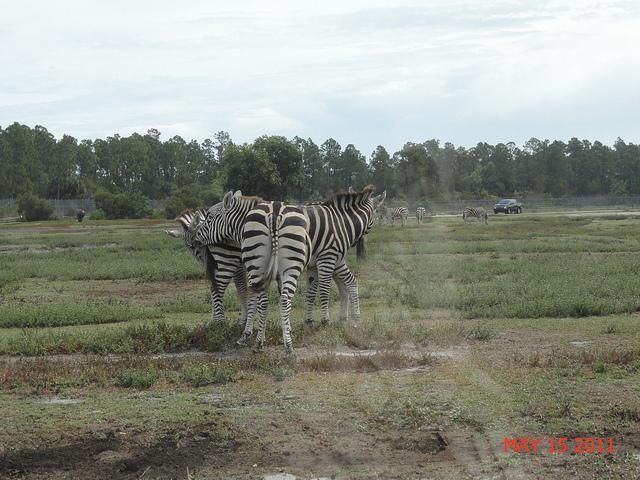How many zebras are in the photo?
Give a very brief answer. 2. How many zebras are in the picture?
Give a very brief answer. 3. How many birds are in the water?
Give a very brief answer. 0. 